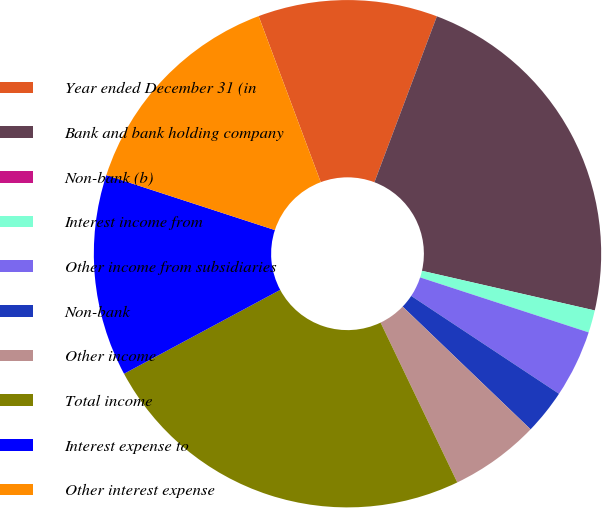Convert chart to OTSL. <chart><loc_0><loc_0><loc_500><loc_500><pie_chart><fcel>Year ended December 31 (in<fcel>Bank and bank holding company<fcel>Non-bank (b)<fcel>Interest income from<fcel>Other income from subsidiaries<fcel>Non-bank<fcel>Other income<fcel>Total income<fcel>Interest expense to<fcel>Other interest expense<nl><fcel>11.43%<fcel>22.86%<fcel>0.0%<fcel>1.43%<fcel>4.29%<fcel>2.86%<fcel>5.71%<fcel>24.28%<fcel>12.86%<fcel>14.29%<nl></chart> 